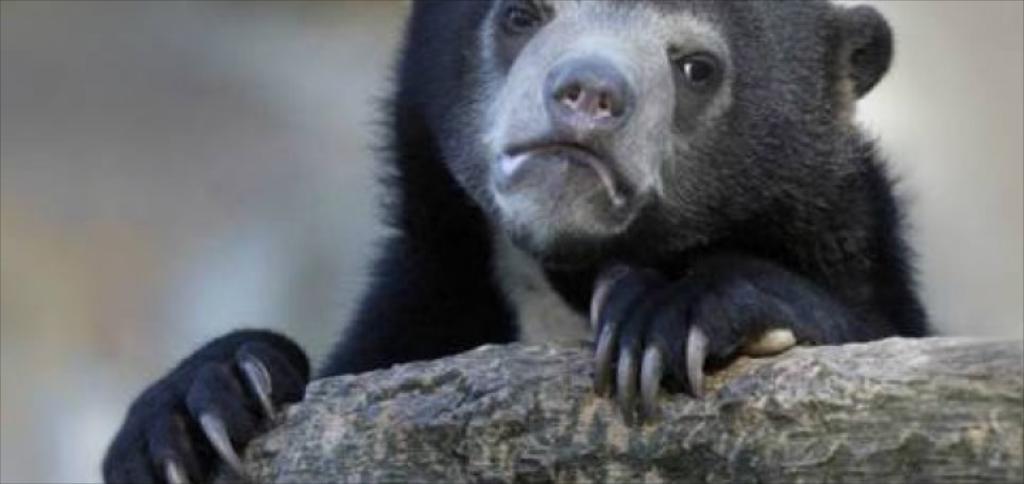Please provide a concise description of this image. In this image, we can see an animal holding an object and the background is blurred. 